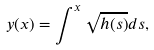<formula> <loc_0><loc_0><loc_500><loc_500>y ( x ) = \int ^ { x } \sqrt { h ( s ) } d s ,</formula> 